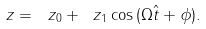<formula> <loc_0><loc_0><loc_500><loc_500>\ z = \ z _ { 0 } + \ z _ { 1 } \cos { ( \Omega \hat { t } + \phi ) } .</formula> 